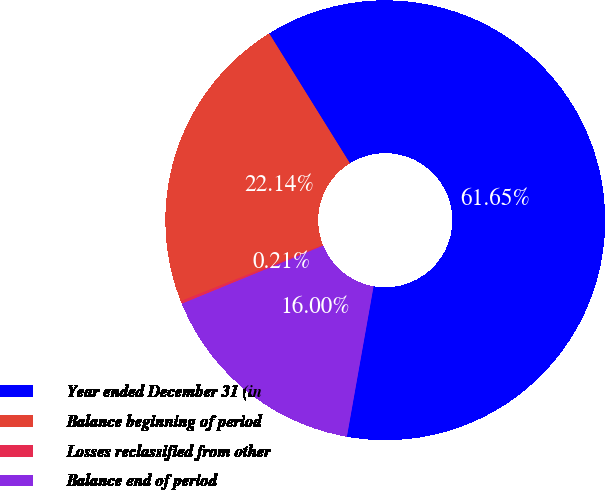<chart> <loc_0><loc_0><loc_500><loc_500><pie_chart><fcel>Year ended December 31 (in<fcel>Balance beginning of period<fcel>Losses reclassified from other<fcel>Balance end of period<nl><fcel>61.65%<fcel>22.14%<fcel>0.21%<fcel>16.0%<nl></chart> 